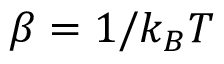Convert formula to latex. <formula><loc_0><loc_0><loc_500><loc_500>\beta = 1 / k _ { B } T</formula> 